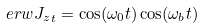Convert formula to latex. <formula><loc_0><loc_0><loc_500><loc_500>\ e r w { J _ { z } } _ { t } = \cos ( \omega _ { 0 } t ) \cos ( \omega _ { b } t )</formula> 